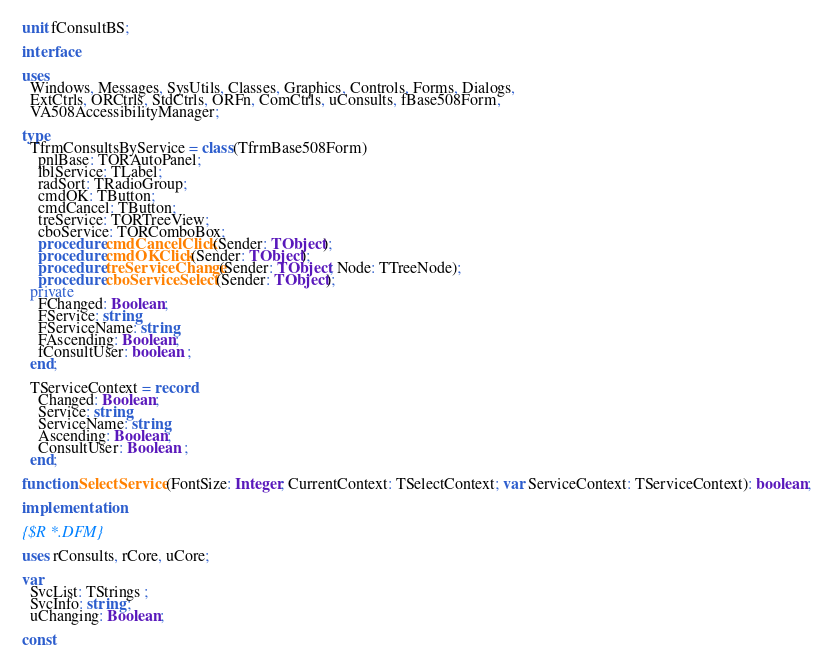<code> <loc_0><loc_0><loc_500><loc_500><_Pascal_>unit fConsultBS;

interface

uses
  Windows, Messages, SysUtils, Classes, Graphics, Controls, Forms, Dialogs,
  ExtCtrls, ORCtrls, StdCtrls, ORFn, ComCtrls, uConsults, fBase508Form,
  VA508AccessibilityManager;

type
  TfrmConsultsByService = class(TfrmBase508Form)
    pnlBase: TORAutoPanel;
    lblService: TLabel;
    radSort: TRadioGroup;
    cmdOK: TButton;
    cmdCancel: TButton;
    treService: TORTreeView;
    cboService: TORComboBox;
    procedure cmdCancelClick(Sender: TObject);
    procedure cmdOKClick(Sender: TObject);
    procedure treServiceChange(Sender: TObject; Node: TTreeNode);
    procedure cboServiceSelect(Sender: TObject);
  private
    FChanged: Boolean;
    FService: string;
    FServiceName: string;
    FAscending: Boolean;
    fConsultUser: boolean ;
  end;

  TServiceContext = record
    Changed: Boolean;
    Service: string;
    ServiceName: string;
    Ascending: Boolean;
    ConsultUser: Boolean ;
  end;

function SelectService(FontSize: Integer; CurrentContext: TSelectContext; var ServiceContext: TServiceContext): boolean;

implementation

{$R *.DFM}

uses rConsults, rCore, uCore;

var
  SvcList: TStrings ;
  SvcInfo: string ;
  uChanging: Boolean;

const</code> 